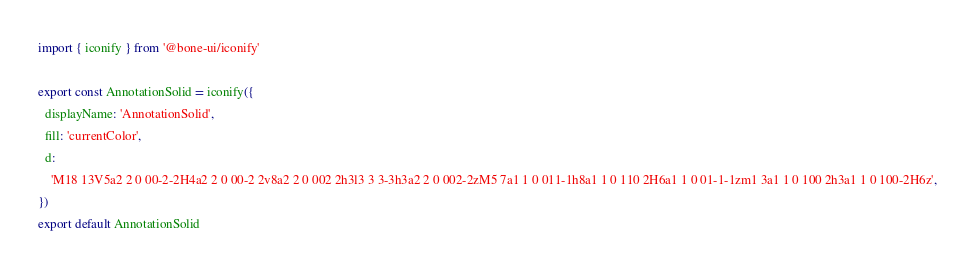<code> <loc_0><loc_0><loc_500><loc_500><_TypeScript_>import { iconify } from '@bone-ui/iconify'

export const AnnotationSolid = iconify({
  displayName: 'AnnotationSolid',
  fill: 'currentColor',
  d:
    'M18 13V5a2 2 0 00-2-2H4a2 2 0 00-2 2v8a2 2 0 002 2h3l3 3 3-3h3a2 2 0 002-2zM5 7a1 1 0 011-1h8a1 1 0 110 2H6a1 1 0 01-1-1zm1 3a1 1 0 100 2h3a1 1 0 100-2H6z',
})
export default AnnotationSolid
</code> 